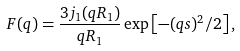<formula> <loc_0><loc_0><loc_500><loc_500>F ( q ) = \frac { 3 j _ { 1 } ( q R _ { 1 } ) } { q R _ { 1 } } \exp { \left [ - ( q s ) ^ { 2 } / 2 \right ] } \, ,</formula> 